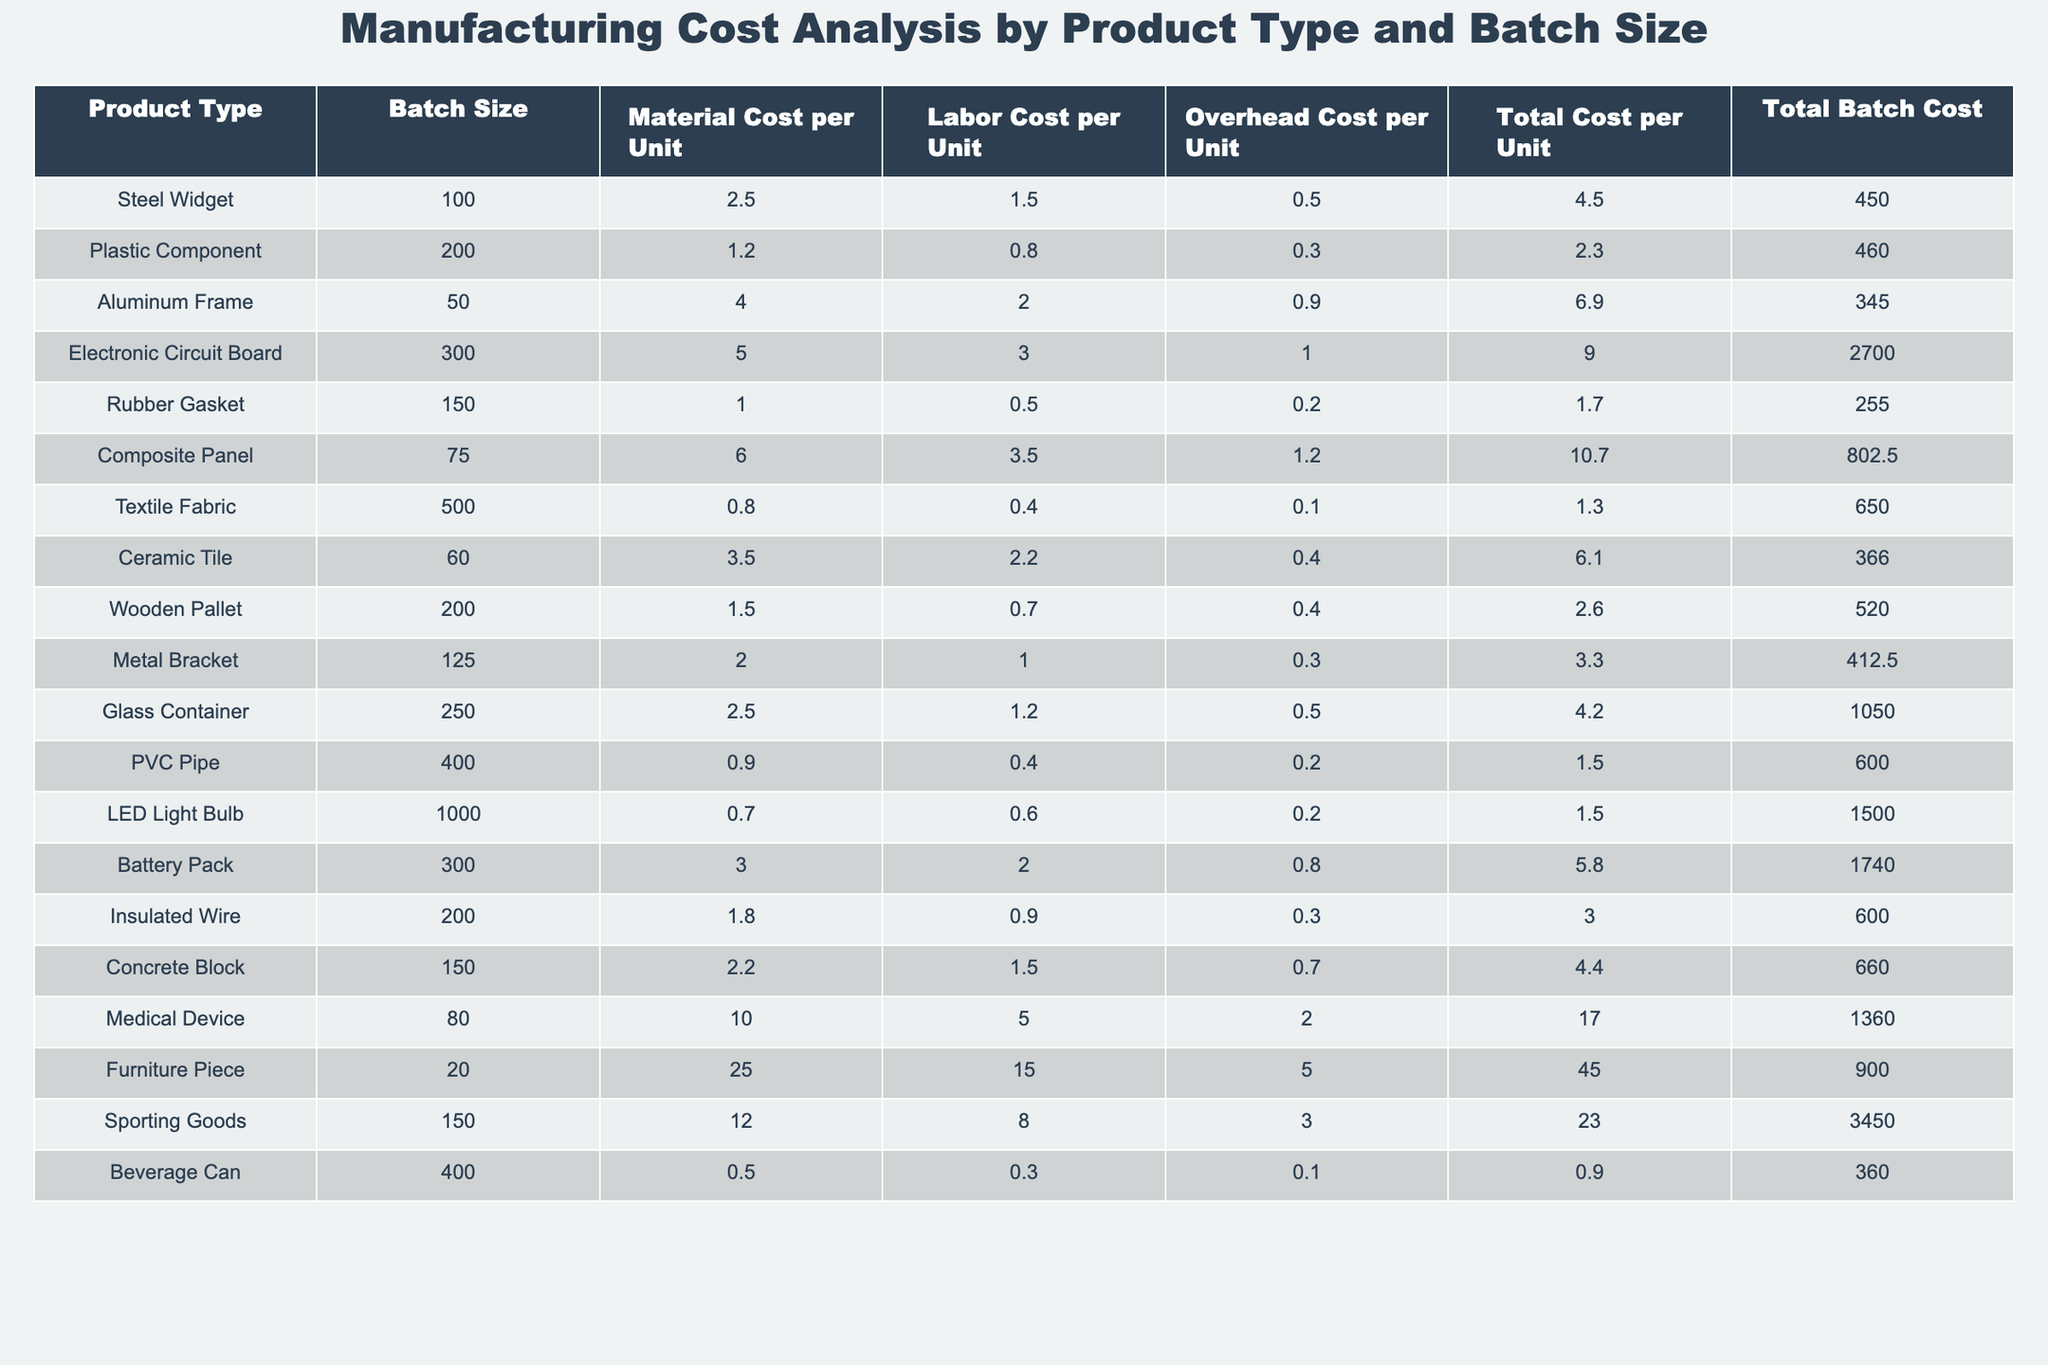What is the total cost per unit of the Steel Widget? The total cost per unit for the Steel Widget is listed in the table under "Total Cost per Unit" for that product type. It shows the value as 4.5.
Answer: 4.5 How many units are in the batch for the Plastic Component? The batch size for the Plastic Component is displayed in the "Batch Size" column, which shows the value as 200.
Answer: 200 What is the material cost per unit for the Aluminum Frame? The material cost per unit for the Aluminum Frame can be found in the "Material Cost per Unit" column, which indicates the cost as 4.0.
Answer: 4.0 Which product type has the highest total batch cost? By comparing the "Total Batch Cost" values in the table, the product type with the highest total batch cost is the Sporting Goods at 3450.
Answer: Sporting Goods What is the average total cost per unit of all the products listed? To find the average total cost per unit, we sum the "Total Cost per Unit" values for all products and then divide by the total number of products (15). The sum is 4.5 + 2.3 + 6.9 + 9.0 + 1.7 + 10.7 + 1.3 + 6.1 + 2.6 + 3.3 + 4.2 + 1.5 + 5.8 + 4.4 + 17.0 + 45.0 = 117.6. Dividing this by 15 gives an average of 7.84.
Answer: 7.84 Is the labor cost per unit for the LED Light Bulb greater than the material cost per unit? From the table, the labor cost per unit for the LED Light Bulb is 0.6 and the material cost is 0.7. Since 0.6 is less than 0.7, the answer is no.
Answer: No What is the difference between the total batch cost of the Medical Device and the total batch cost of the Wooden Pallet? The total batch cost of the Medical Device is 1360, and for the Wooden Pallet, it is 520. The difference is calculated as 1360 - 520 = 840.
Answer: 840 Which product type has the lowest material cost per unit? By looking at the "Material Cost per Unit" column, the lowest value is 0.5, which belongs to the Beverage Can.
Answer: Beverage Can If you combine the total costs of Rubber Gasket and Metal Bracket, what will the total be? The total costs are 1.7 for Rubber Gasket and 3.3 for Metal Bracket. Adding these two gives 1.7 + 3.3 = 5.0.
Answer: 5.0 Are there any products with a total cost per unit exceeding 10? Checking the "Total Cost per Unit" column, the Medical Device has a total cost of 17.0, which exceeds 10, so the answer is yes.
Answer: Yes What is the total batch size for all products combined? To find the total batch size, we sum the "Batch Size" values for all products: 100 + 200 + 50 + 300 + 150 + 75 + 500 + 60 + 200 + 125 + 250 + 400 + 1000 + 300 + 150 + 20 + 150 + 400 = 3650.
Answer: 3650 